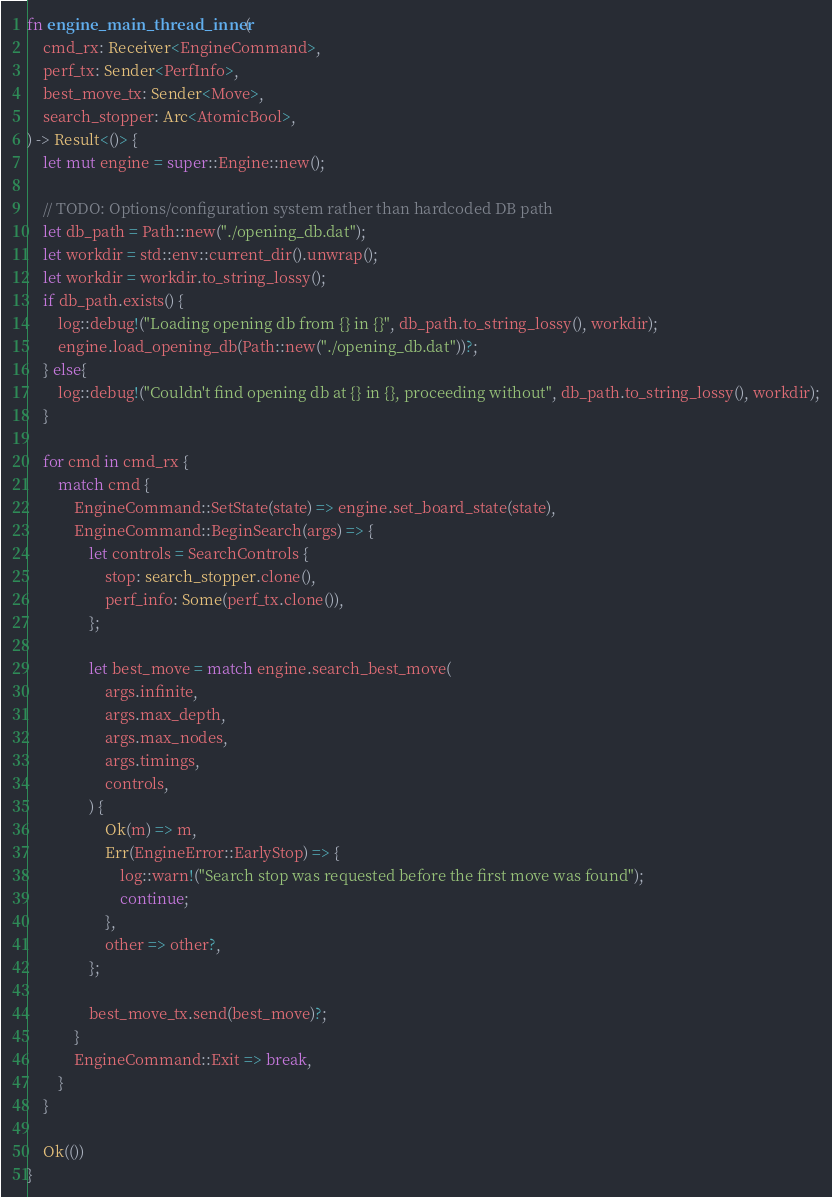Convert code to text. <code><loc_0><loc_0><loc_500><loc_500><_Rust_>fn engine_main_thread_inner(
    cmd_rx: Receiver<EngineCommand>,
    perf_tx: Sender<PerfInfo>,
    best_move_tx: Sender<Move>,
    search_stopper: Arc<AtomicBool>,
) -> Result<()> {
    let mut engine = super::Engine::new();

    // TODO: Options/configuration system rather than hardcoded DB path
    let db_path = Path::new("./opening_db.dat");
    let workdir = std::env::current_dir().unwrap();
    let workdir = workdir.to_string_lossy();
    if db_path.exists() {
        log::debug!("Loading opening db from {} in {}", db_path.to_string_lossy(), workdir);
        engine.load_opening_db(Path::new("./opening_db.dat"))?;
    } else{
        log::debug!("Couldn't find opening db at {} in {}, proceeding without", db_path.to_string_lossy(), workdir);
    }

    for cmd in cmd_rx {
        match cmd {
            EngineCommand::SetState(state) => engine.set_board_state(state),
            EngineCommand::BeginSearch(args) => {
                let controls = SearchControls {
                    stop: search_stopper.clone(),
                    perf_info: Some(perf_tx.clone()),
                };

                let best_move = match engine.search_best_move(
                    args.infinite,
                    args.max_depth,
                    args.max_nodes,
                    args.timings,
                    controls,
                ) {
                    Ok(m) => m,
                    Err(EngineError::EarlyStop) => {
                        log::warn!("Search stop was requested before the first move was found");
                        continue;
                    },
                    other => other?,
                };

                best_move_tx.send(best_move)?;
            }
            EngineCommand::Exit => break,
        }
    }

    Ok(())
}
</code> 